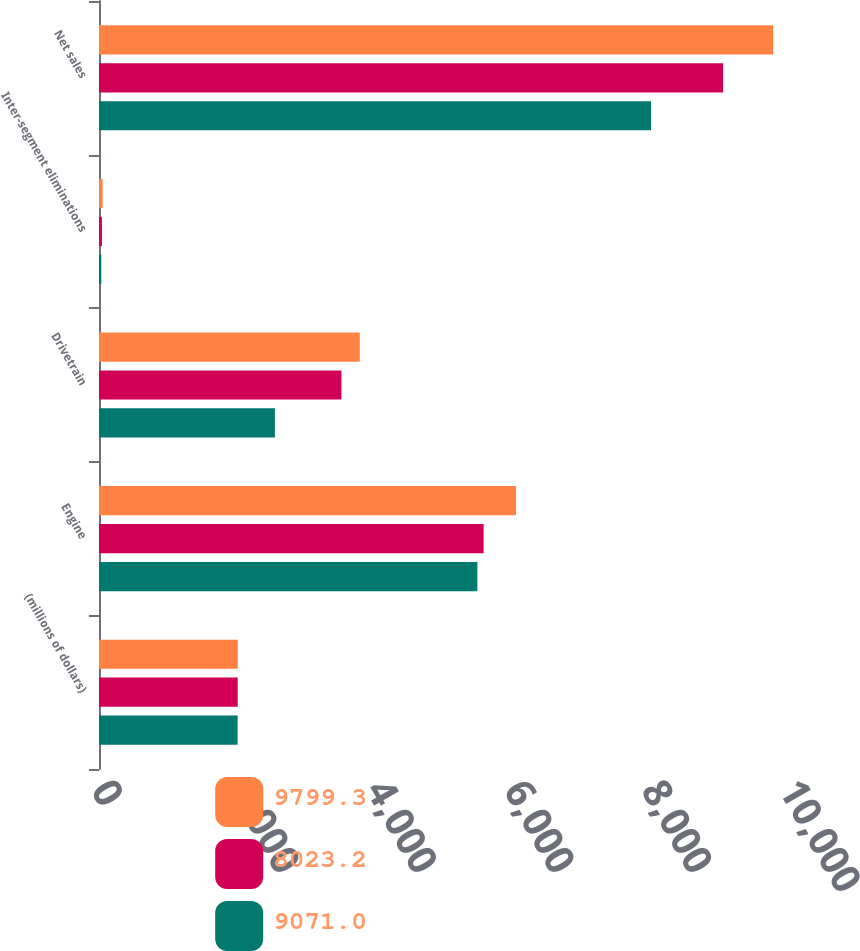<chart> <loc_0><loc_0><loc_500><loc_500><stacked_bar_chart><ecel><fcel>(millions of dollars)<fcel>Engine<fcel>Drivetrain<fcel>Inter-segment eliminations<fcel>Net sales<nl><fcel>9799.3<fcel>2017<fcel>6061.5<fcel>3790.3<fcel>52.5<fcel>9799.3<nl><fcel>8023.2<fcel>2016<fcel>5590.1<fcel>3523.7<fcel>42.8<fcel>9071<nl><fcel>9071<fcel>2015<fcel>5500<fcel>2556.7<fcel>33.5<fcel>8023.2<nl></chart> 